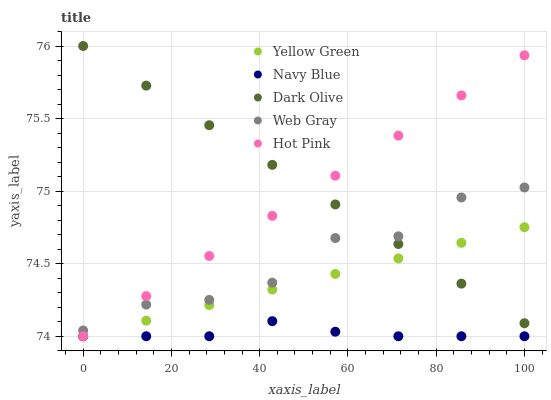Does Navy Blue have the minimum area under the curve?
Answer yes or no. Yes. Does Dark Olive have the maximum area under the curve?
Answer yes or no. Yes. Does Web Gray have the minimum area under the curve?
Answer yes or no. No. Does Web Gray have the maximum area under the curve?
Answer yes or no. No. Is Dark Olive the smoothest?
Answer yes or no. Yes. Is Web Gray the roughest?
Answer yes or no. Yes. Is Web Gray the smoothest?
Answer yes or no. No. Is Dark Olive the roughest?
Answer yes or no. No. Does Navy Blue have the lowest value?
Answer yes or no. Yes. Does Web Gray have the lowest value?
Answer yes or no. No. Does Dark Olive have the highest value?
Answer yes or no. Yes. Does Web Gray have the highest value?
Answer yes or no. No. Is Navy Blue less than Web Gray?
Answer yes or no. Yes. Is Dark Olive greater than Navy Blue?
Answer yes or no. Yes. Does Hot Pink intersect Dark Olive?
Answer yes or no. Yes. Is Hot Pink less than Dark Olive?
Answer yes or no. No. Is Hot Pink greater than Dark Olive?
Answer yes or no. No. Does Navy Blue intersect Web Gray?
Answer yes or no. No. 